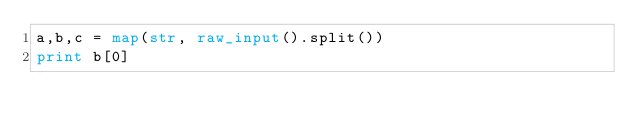Convert code to text. <code><loc_0><loc_0><loc_500><loc_500><_Python_>a,b,c = map(str, raw_input().split())
print b[0]</code> 